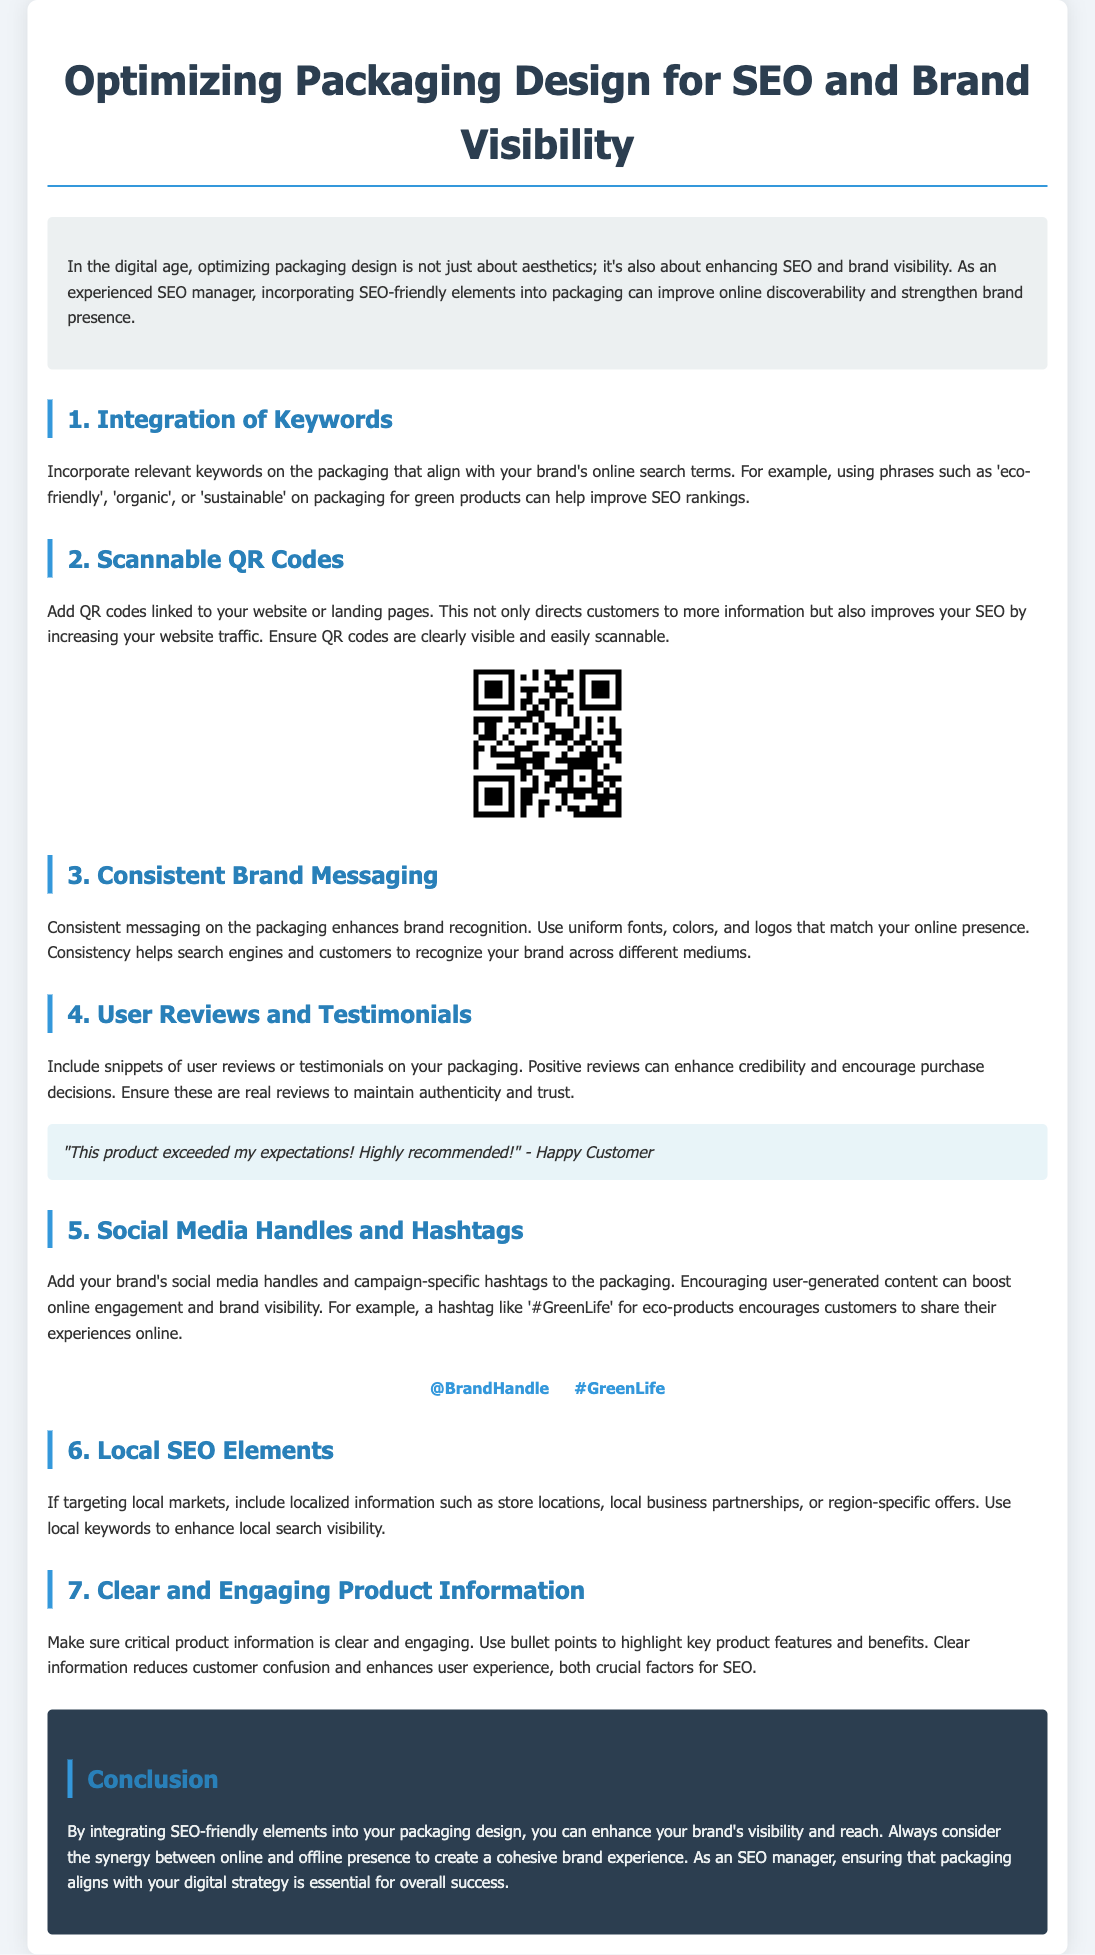What is the title of the document? The title is found in the header section of the document.
Answer: Optimizing Packaging Design for SEO and Brand Visibility What is the first key topic discussed in the document? The first key topic outlined in the document's sections.
Answer: Integration of Keywords What element can be added to improve website traffic? The document specifies a key element for directing customers to online resources.
Answer: QR Codes What is one benefit of consistent brand messaging? This can be inferred from the section discussing brand recognition and visibility.
Answer: Brand recognition What type of content encourages user-generated engagement? The document mentions a specific type of information that motivates customers to share experiences.
Answer: Social Media Handles and Hashtags How many key topics are covered in the document? The document contains several numbered sections, indicating the count of discussed topics.
Answer: 7 What visual element is included to demonstrate QR code usage? The document includes a specific visual representation.
Answer: QR Code What is an example of a keyword for eco-friendly products? The document provides specific keyword examples related to sustainable products.
Answer: Sustainable What kind of product information should be provided on packaging? This can be determined from the section about customer confusion and user experience.
Answer: Clear and Engaging Product Information 